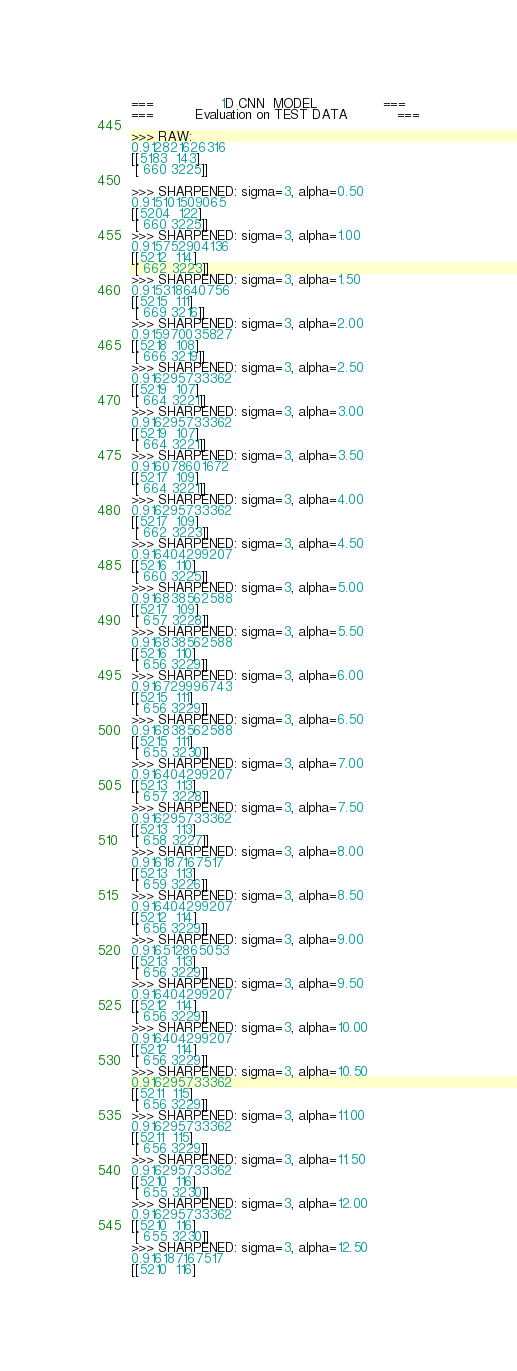<code> <loc_0><loc_0><loc_500><loc_500><_Python_>===                1D CNN  MODEL                ===
===          Evaluation on TEST DATA            ===

>>> RAW:
0.912821626316
[[5183  143]
 [ 660 3225]] 

>>> SHARPENED: sigma=3, alpha=0.50
0.915101509065
[[5204  122]
 [ 660 3225]]
>>> SHARPENED: sigma=3, alpha=1.00
0.915752904136
[[5212  114]
 [ 662 3223]]
>>> SHARPENED: sigma=3, alpha=1.50
0.915318640756
[[5215  111]
 [ 669 3216]]
>>> SHARPENED: sigma=3, alpha=2.00
0.915970035827
[[5218  108]
 [ 666 3219]]
>>> SHARPENED: sigma=3, alpha=2.50
0.916295733362
[[5219  107]
 [ 664 3221]]
>>> SHARPENED: sigma=3, alpha=3.00
0.916295733362
[[5219  107]
 [ 664 3221]]
>>> SHARPENED: sigma=3, alpha=3.50
0.916078601672
[[5217  109]
 [ 664 3221]]
>>> SHARPENED: sigma=3, alpha=4.00
0.916295733362
[[5217  109]
 [ 662 3223]]
>>> SHARPENED: sigma=3, alpha=4.50
0.916404299207
[[5216  110]
 [ 660 3225]]
>>> SHARPENED: sigma=3, alpha=5.00
0.916838562588
[[5217  109]
 [ 657 3228]]
>>> SHARPENED: sigma=3, alpha=5.50
0.916838562588
[[5216  110]
 [ 656 3229]]
>>> SHARPENED: sigma=3, alpha=6.00
0.916729996743
[[5215  111]
 [ 656 3229]]
>>> SHARPENED: sigma=3, alpha=6.50
0.916838562588
[[5215  111]
 [ 655 3230]]
>>> SHARPENED: sigma=3, alpha=7.00
0.916404299207
[[5213  113]
 [ 657 3228]]
>>> SHARPENED: sigma=3, alpha=7.50
0.916295733362
[[5213  113]
 [ 658 3227]]
>>> SHARPENED: sigma=3, alpha=8.00
0.916187167517
[[5213  113]
 [ 659 3226]]
>>> SHARPENED: sigma=3, alpha=8.50
0.916404299207
[[5212  114]
 [ 656 3229]]
>>> SHARPENED: sigma=3, alpha=9.00
0.916512865053
[[5213  113]
 [ 656 3229]]
>>> SHARPENED: sigma=3, alpha=9.50
0.916404299207
[[5212  114]
 [ 656 3229]]
>>> SHARPENED: sigma=3, alpha=10.00
0.916404299207
[[5212  114]
 [ 656 3229]]
>>> SHARPENED: sigma=3, alpha=10.50
0.916295733362
[[5211  115]
 [ 656 3229]]
>>> SHARPENED: sigma=3, alpha=11.00
0.916295733362
[[5211  115]
 [ 656 3229]]
>>> SHARPENED: sigma=3, alpha=11.50
0.916295733362
[[5210  116]
 [ 655 3230]]
>>> SHARPENED: sigma=3, alpha=12.00
0.916295733362
[[5210  116]
 [ 655 3230]]
>>> SHARPENED: sigma=3, alpha=12.50
0.916187167517
[[5210  116]</code> 